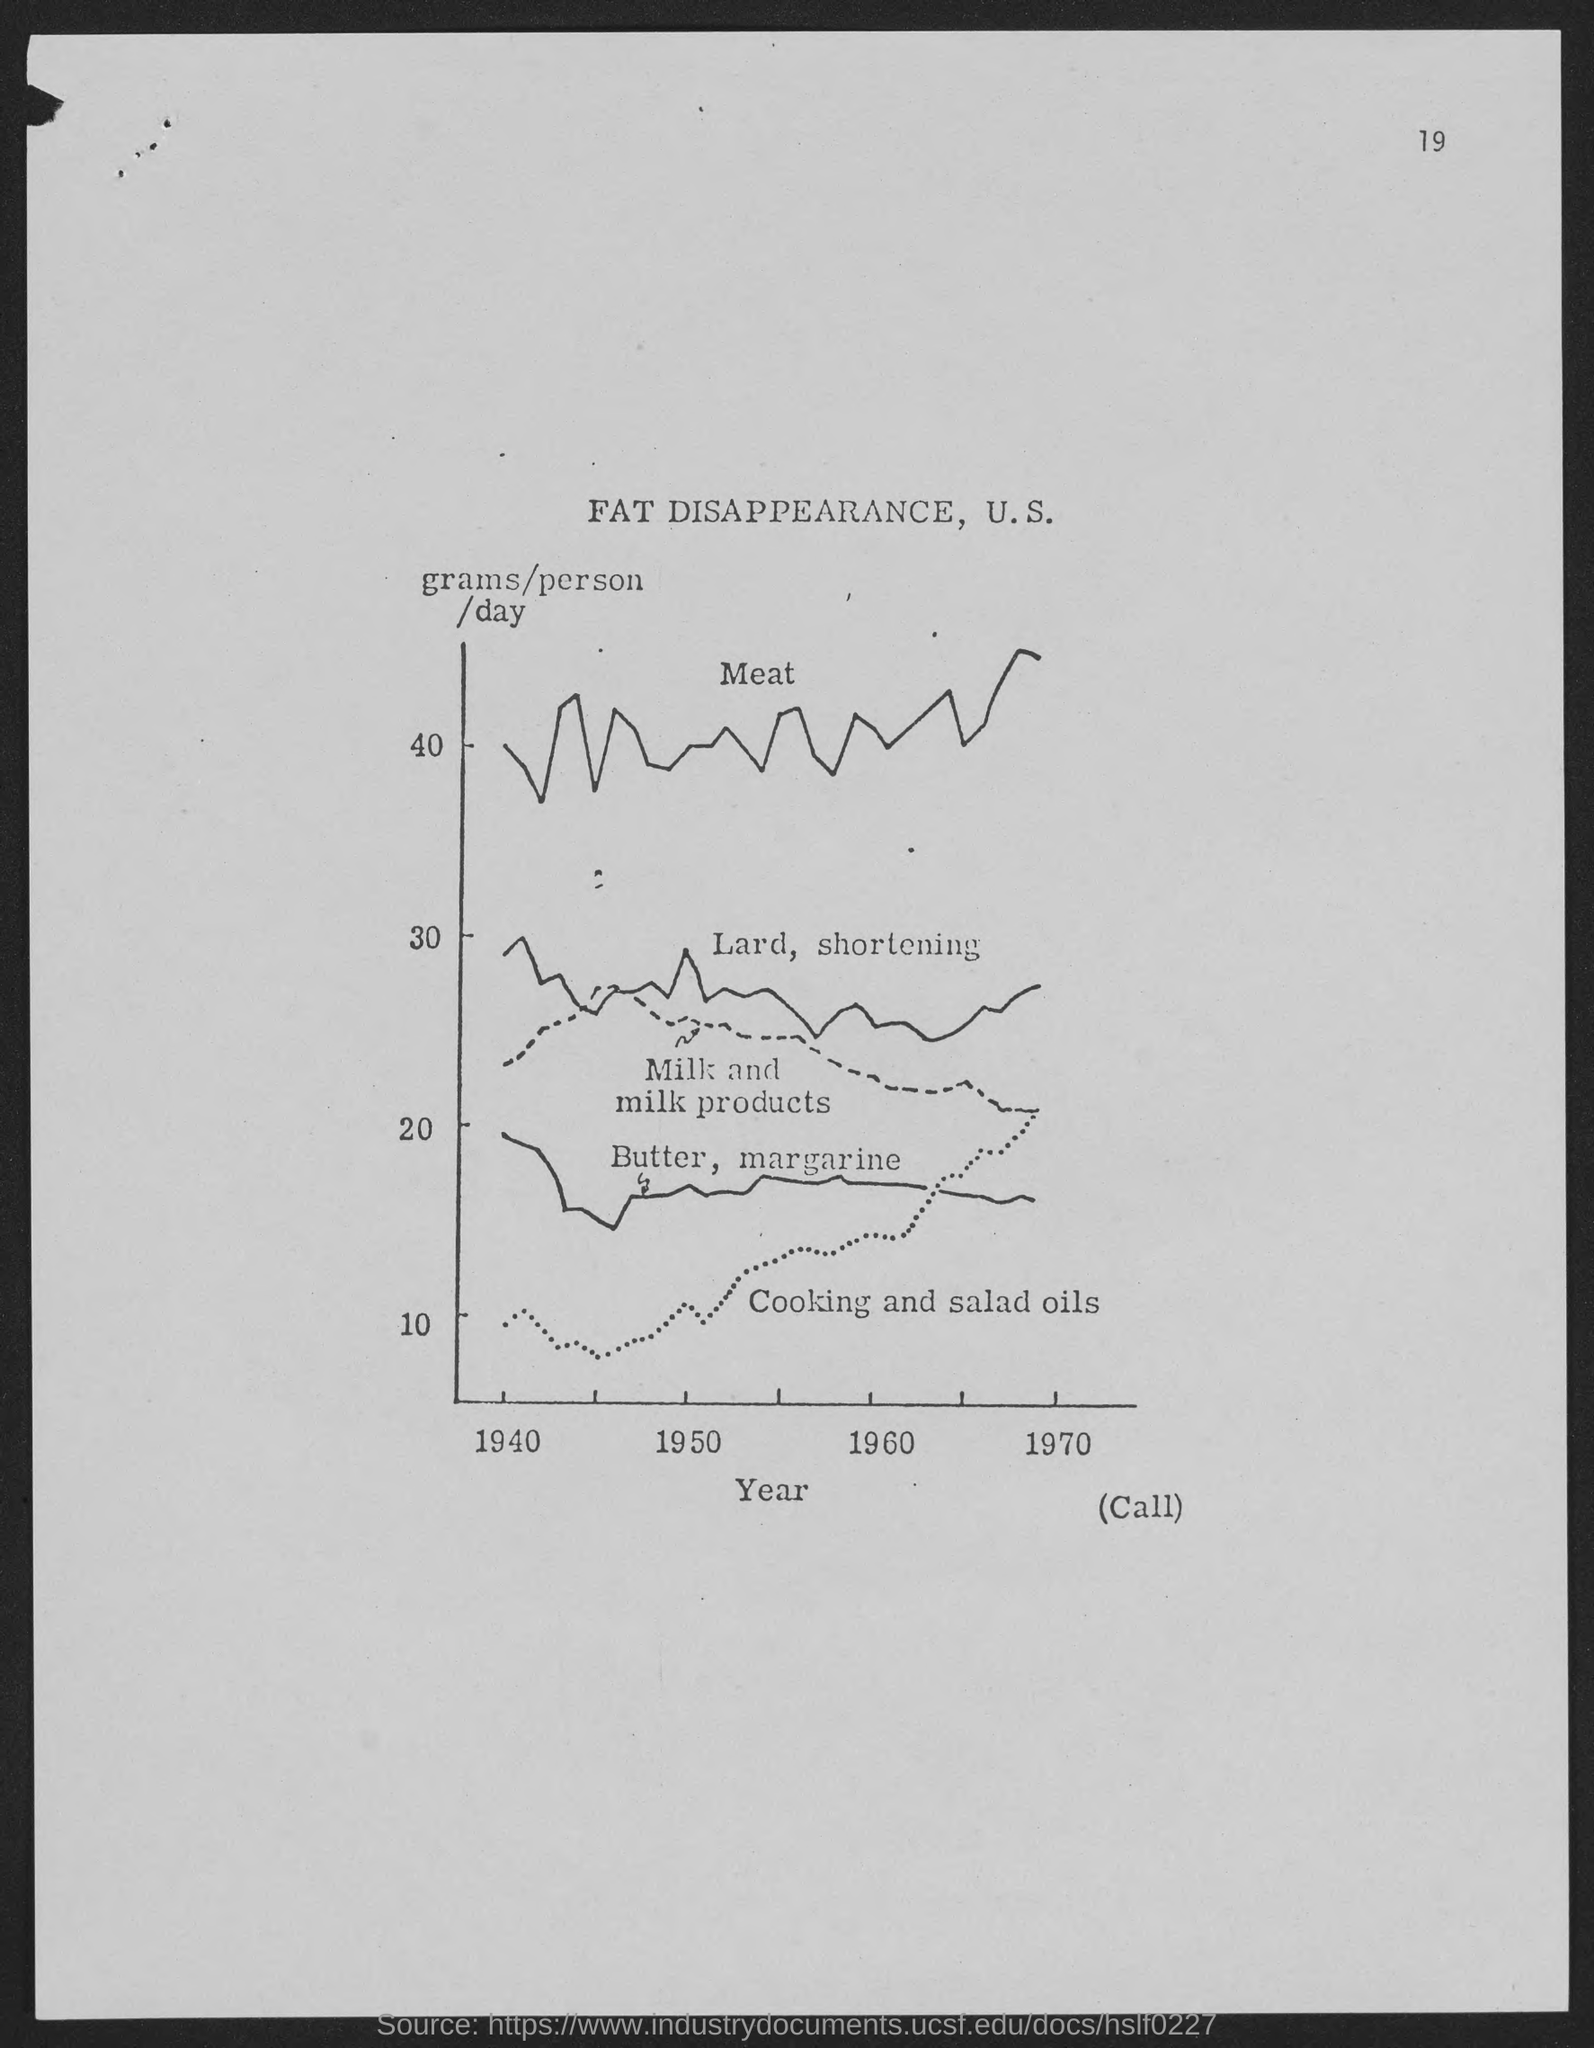Draw attention to some important aspects in this diagram. The number at the top-right corner of the page is 19. 